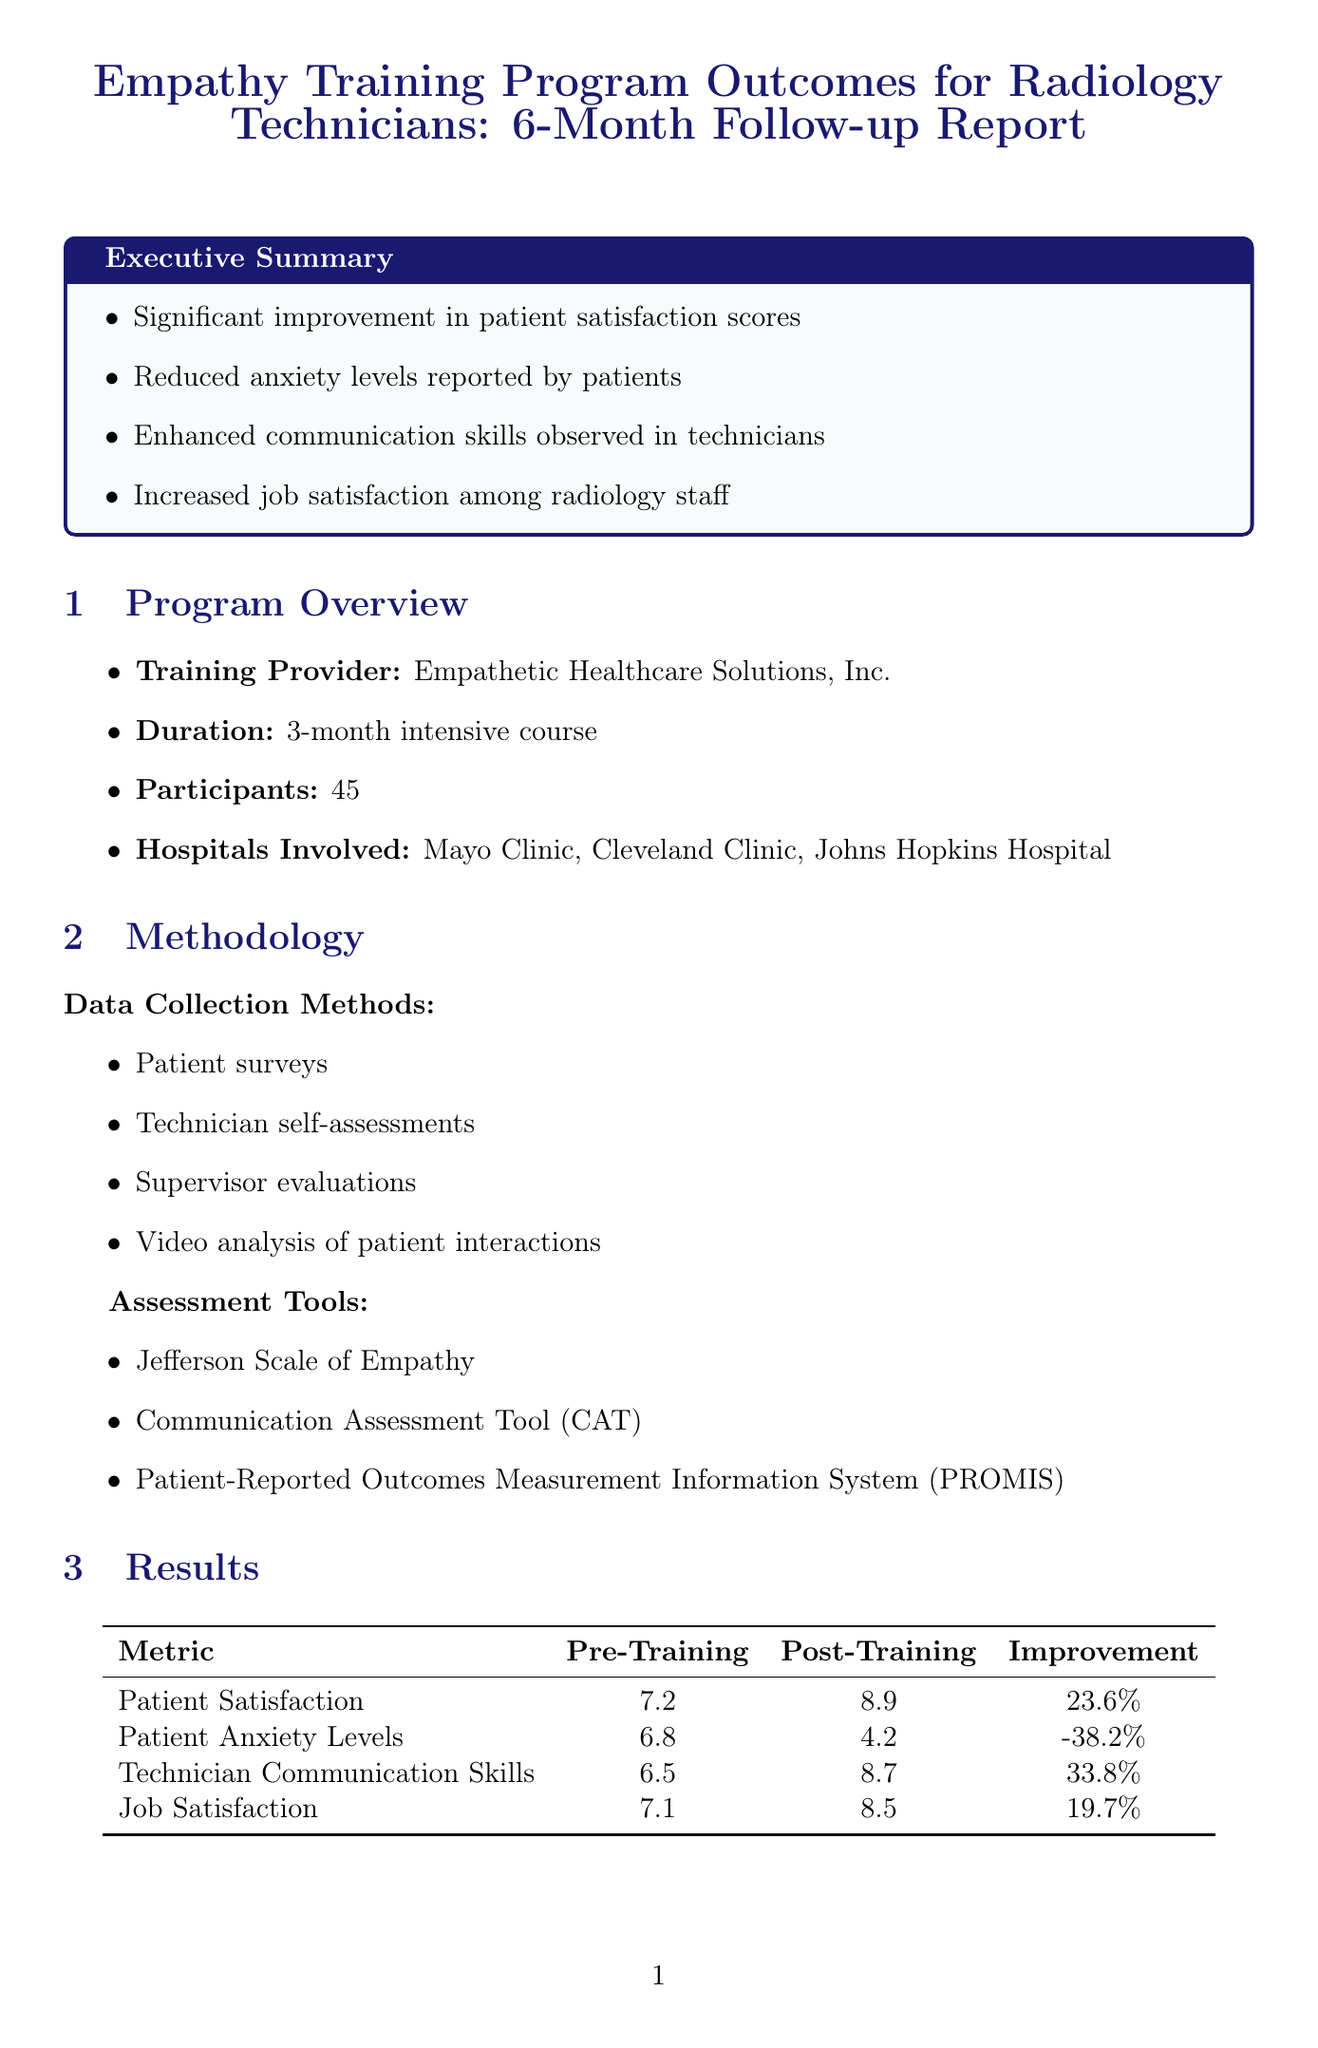what is the title of the report? The title of the report is explicitly mentioned at the beginning of the document.
Answer: Empathy Training Program Outcomes for Radiology Technicians: 6-Month Follow-up Report who provided the training? The training provider is specified in the program overview section of the document.
Answer: Empathetic Healthcare Solutions, Inc what was the duration of the training course? The duration of the training is clearly stated in the program overview.
Answer: 3-month intensive course how many hospitals were involved in the training? The count of hospitals is mentioned in the program overview section of the document.
Answer: 3 what was the patient satisfaction score before training? The pre-training average score for patient satisfaction is provided in the results section.
Answer: 7.2 which assessment tool is mentioned for measuring communication skills? The document lists specific assessment tools used in the methodology section.
Answer: Communication Assessment Tool (CAT) what percentage did patient anxiety levels reduce after training? The document provides the reduction percentage in patient anxiety levels in the results section.
Answer: 38.2% what future recommendation is suggested regarding technician mentorship? The recommendations include suggestions for technician mentorship in the future recommendations section.
Answer: Develop a mentorship program pairing high-empathy technicians with newcomers what challenges were faced regarding technician communication styles? Specific challenges faced are outlined in the challenges and improvements section.
Answer: Initial resistance from some technicians to change communication styles what is the conclusion about the empathy training program? The conclusion summarizes the outcomes and impacts of the program directly.
Answer: Significant positive outcomes in improving patient experience and technician performance 